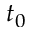Convert formula to latex. <formula><loc_0><loc_0><loc_500><loc_500>t _ { 0 }</formula> 